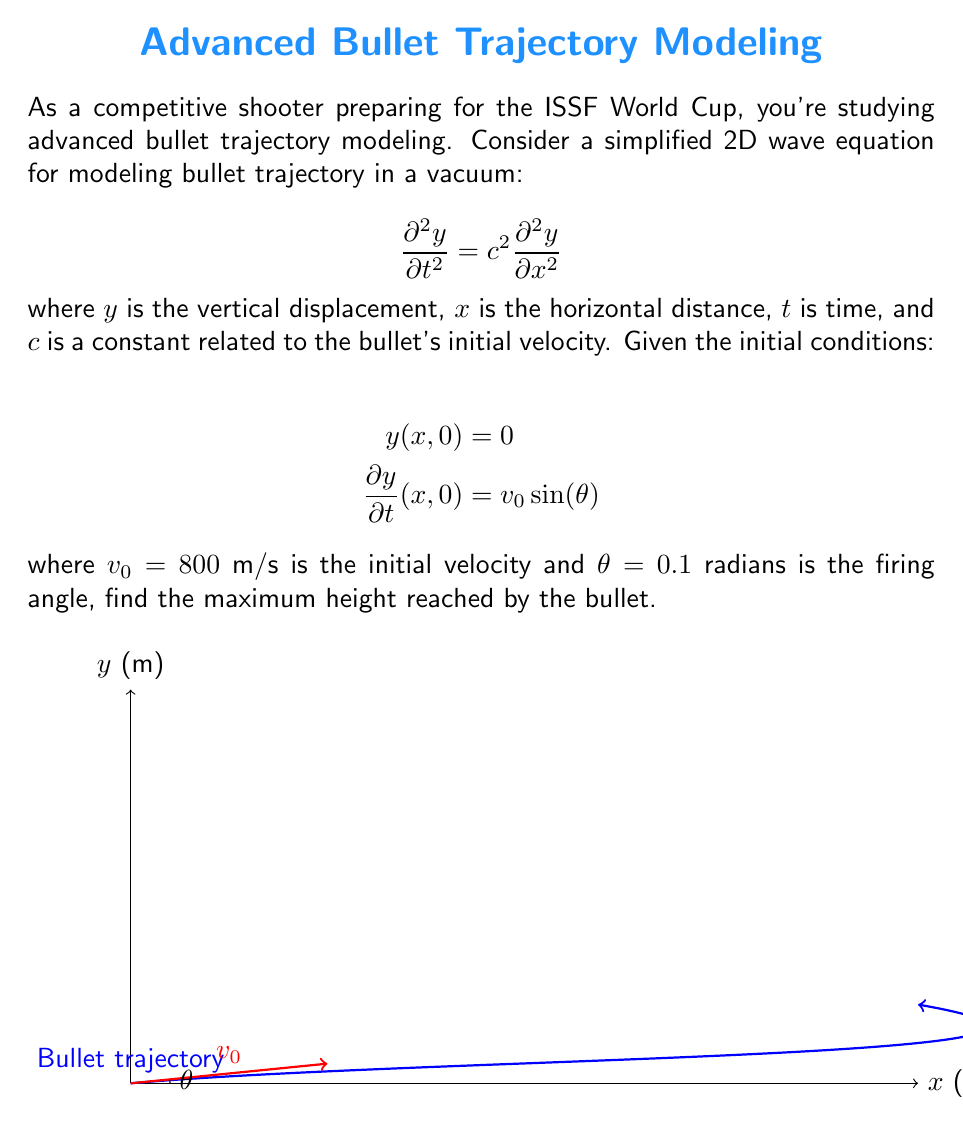Help me with this question. Let's approach this step-by-step:

1) The general solution to the 2D wave equation is:
   $$y(x,t) = f(x-ct) + g(x+ct)$$
   where $f$ and $g$ are arbitrary functions.

2) Given the initial condition $y(x,0) = 0$, we can deduce that $f(x) = -g(x)$.

3) The second initial condition gives us:
   $$\frac{\partial y}{\partial t}(x,0) = c[f'(x) - g'(x)] = v_0 \sin(\theta)$$

4) Since $f(x) = -g(x)$, we have $f'(x) = -g'(x)$, so:
   $$2cf'(x) = v_0 \sin(\theta)$$
   $$f'(x) = \frac{v_0 \sin(\theta)}{2c}$$

5) Integrating both sides:
   $$f(x) = \frac{v_0 \sin(\theta)}{2c}x + C$$

6) The complete solution is therefore:
   $$y(x,t) = \frac{v_0 \sin(\theta)}{2c}(x-ct) - \frac{v_0 \sin(\theta)}{2c}(x+ct) = -v_0 \sin(\theta)t$$

7) This represents a parabolic trajectory. The maximum height is reached when $t = \frac{v_0 \sin(\theta)}{g}$, where $g$ is the acceleration due to gravity (9.8 m/s²).

8) Substituting the given values:
   $$t_{max} = \frac{800 \sin(0.1)}{9.8} \approx 8.16 \text{ s}$$

9) The maximum height is then:
   $$y_{max} = v_0 \sin(\theta) \cdot \frac{v_0 \sin(\theta)}{2g} = \frac{(v_0 \sin(\theta))^2}{2g}$$

10) Plugging in the values:
    $$y_{max} = \frac{(800 \sin(0.1))^2}{2(9.8)} \approx 326.53 \text{ m}$$
Answer: 326.53 m 